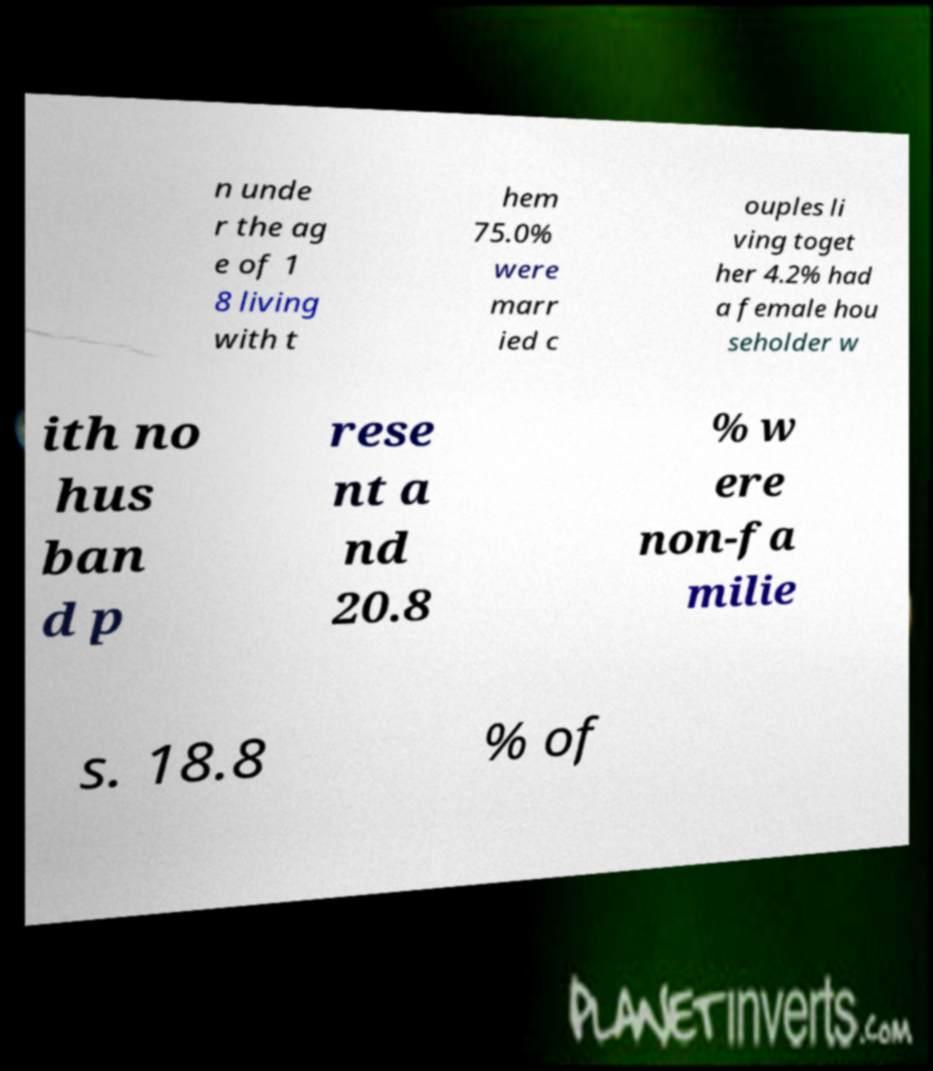Could you extract and type out the text from this image? n unde r the ag e of 1 8 living with t hem 75.0% were marr ied c ouples li ving toget her 4.2% had a female hou seholder w ith no hus ban d p rese nt a nd 20.8 % w ere non-fa milie s. 18.8 % of 